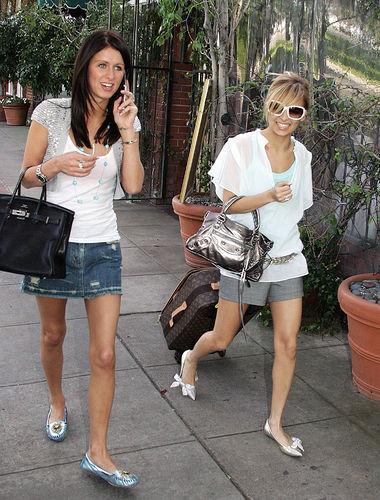How many people are walking?
Give a very brief answer. 2. How many potted plants can be seen?
Give a very brief answer. 3. How many handbags are there?
Give a very brief answer. 2. How many people can you see?
Give a very brief answer. 2. 